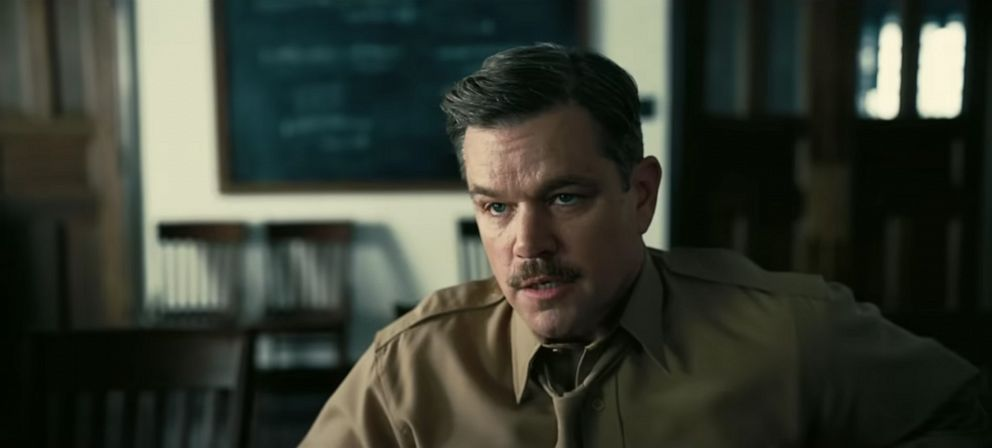 This scene presents a thoughtful individual in what seems to be an academic setting. Any thoughts on what he might be thinking about? He looks quite intent. Perhaps he is reviewing some important research findings or preparing a lecture? Absolutely, the intense focus and academic backdrop suggest that he might be preparing for an important lecture or revisiting key research findings. The mustache and attire add a touch of gravitas, implying a person of experience and knowledge. Let's imagine he's working on a groundbreaking theory. What could it be about? Perhaps he's developing a new theoretical framework that combines quantum mechanics with general relativity, aiming to unify the laws governing the cosmos on both the microscopic and macroscopic scales. Or maybe he's devising an innovative approach to sustainable energy, blending advanced physics with cutting-edge technology to address global challenges. That's fascinating! On a different note, what if the equations on the blackboard were actually a secret code? Imagine the equations are indeed a secret code, perhaps leading to the discovery of a hidden treasure or revealing a complex conspiracy. The protagonist, decrypting these intricate symbols, could be on the brink of uncovering a truth that changes the course of history. This intellectual pursuit transforms into a thrilling adventure filled with mystery and suspense. 